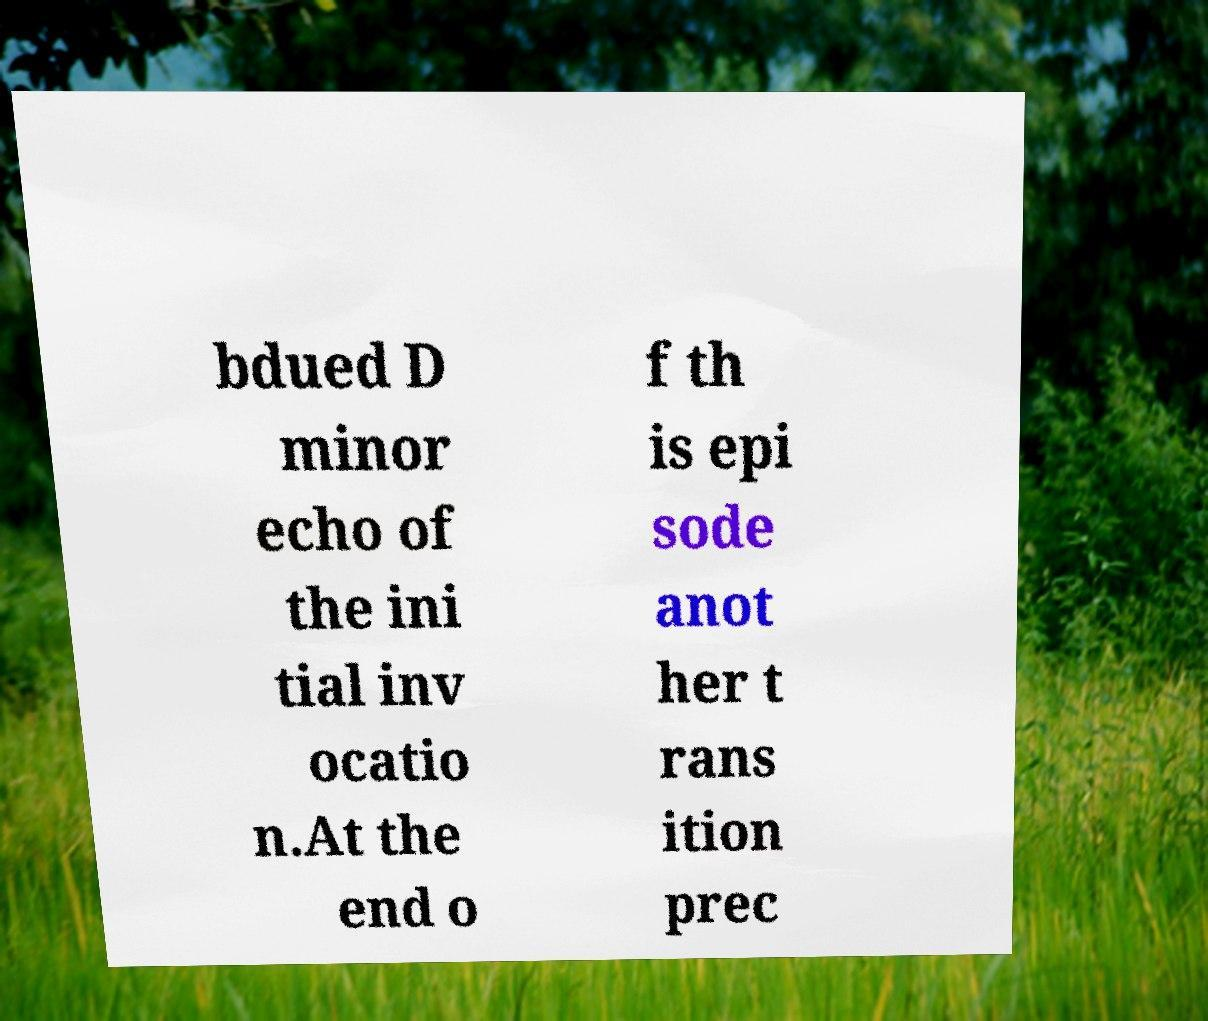Can you accurately transcribe the text from the provided image for me? bdued D minor echo of the ini tial inv ocatio n.At the end o f th is epi sode anot her t rans ition prec 